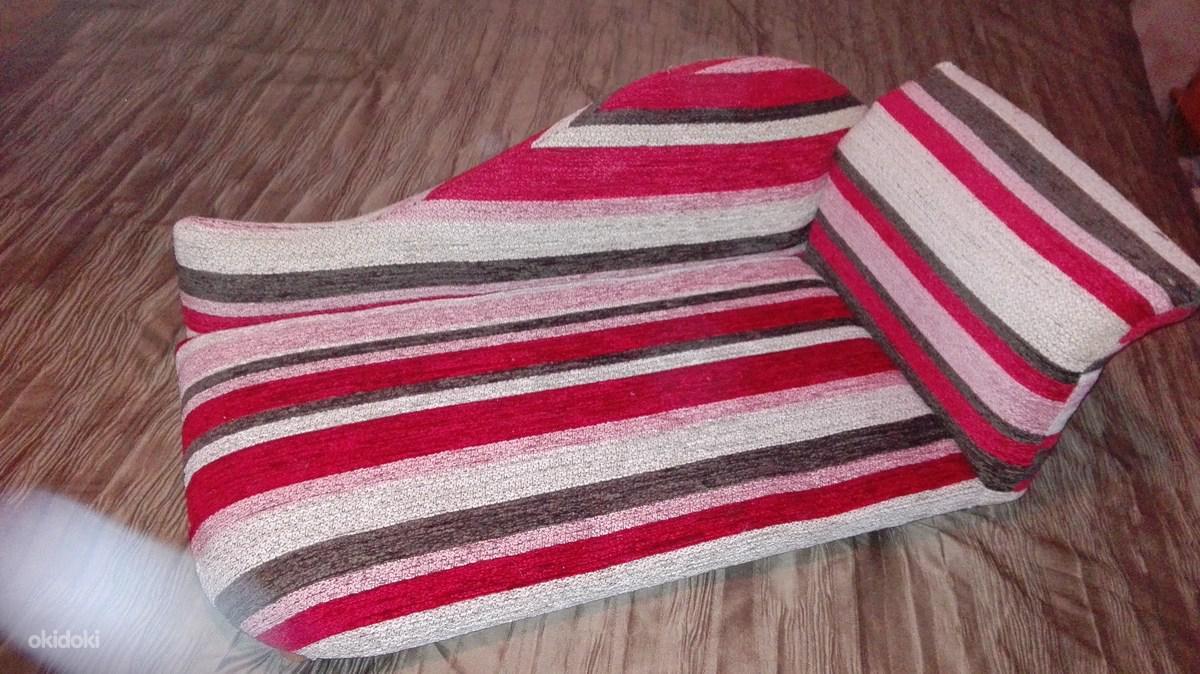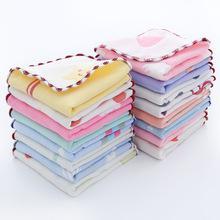The first image is the image on the left, the second image is the image on the right. Given the left and right images, does the statement "All towels shown are solid colored, and at least one image shows a vertical stack of four different colored folded towels." hold true? Answer yes or no. No. The first image is the image on the left, the second image is the image on the right. Analyze the images presented: Is the assertion "The left and right image contains the same number of fold or rolled towels." valid? Answer yes or no. No. 